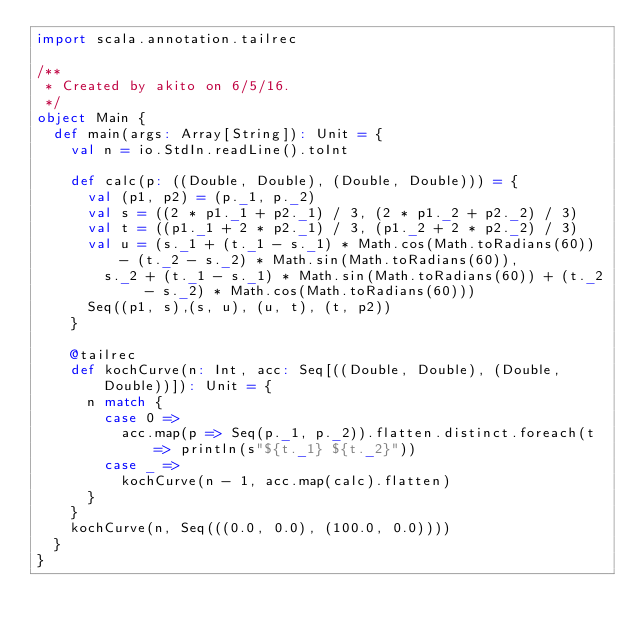<code> <loc_0><loc_0><loc_500><loc_500><_Scala_>import scala.annotation.tailrec

/**
 * Created by akito on 6/5/16.
 */
object Main {
  def main(args: Array[String]): Unit = {
    val n = io.StdIn.readLine().toInt

    def calc(p: ((Double, Double), (Double, Double))) = {
      val (p1, p2) = (p._1, p._2)
      val s = ((2 * p1._1 + p2._1) / 3, (2 * p1._2 + p2._2) / 3)
      val t = ((p1._1 + 2 * p2._1) / 3, (p1._2 + 2 * p2._2) / 3)
      val u = (s._1 + (t._1 - s._1) * Math.cos(Math.toRadians(60)) - (t._2 - s._2) * Math.sin(Math.toRadians(60)),
        s._2 + (t._1 - s._1) * Math.sin(Math.toRadians(60)) + (t._2 - s._2) * Math.cos(Math.toRadians(60)))
      Seq((p1, s),(s, u), (u, t), (t, p2))
    }

    @tailrec
    def kochCurve(n: Int, acc: Seq[((Double, Double), (Double, Double))]): Unit = {
      n match {
        case 0 =>
          acc.map(p => Seq(p._1, p._2)).flatten.distinct.foreach(t => println(s"${t._1} ${t._2}"))
        case _ =>
          kochCurve(n - 1, acc.map(calc).flatten)
      }
    }
    kochCurve(n, Seq(((0.0, 0.0), (100.0, 0.0))))
  }
}</code> 